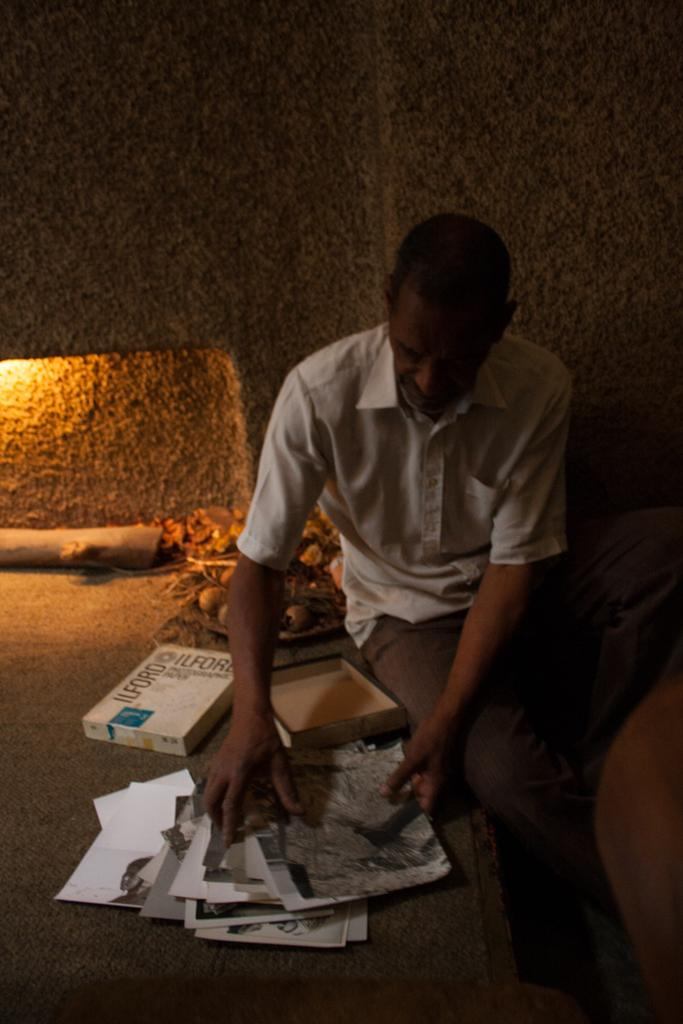What is the person in the image doing? The person is sitting on the ground in the image. What is the person wearing? The person is wearing a white shirt. What objects can be seen on the ground in the image? There are papers and packets on the ground in the image. What feature is present in the background of the image? There is a fireplace in the image. Who is the creator of the circle in the image? There is no circle present in the image. 